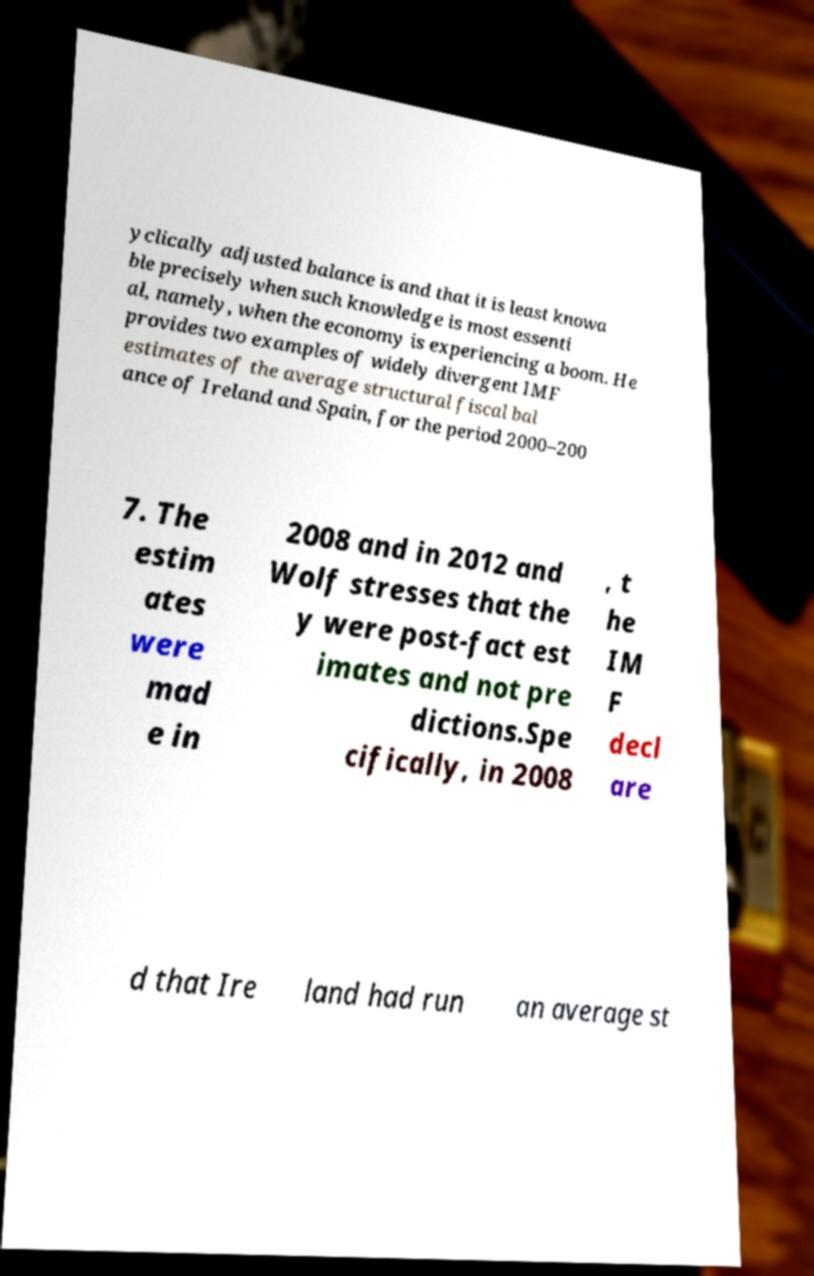Can you read and provide the text displayed in the image?This photo seems to have some interesting text. Can you extract and type it out for me? yclically adjusted balance is and that it is least knowa ble precisely when such knowledge is most essenti al, namely, when the economy is experiencing a boom. He provides two examples of widely divergent IMF estimates of the average structural fiscal bal ance of Ireland and Spain, for the period 2000–200 7. The estim ates were mad e in 2008 and in 2012 and Wolf stresses that the y were post-fact est imates and not pre dictions.Spe cifically, in 2008 , t he IM F decl are d that Ire land had run an average st 